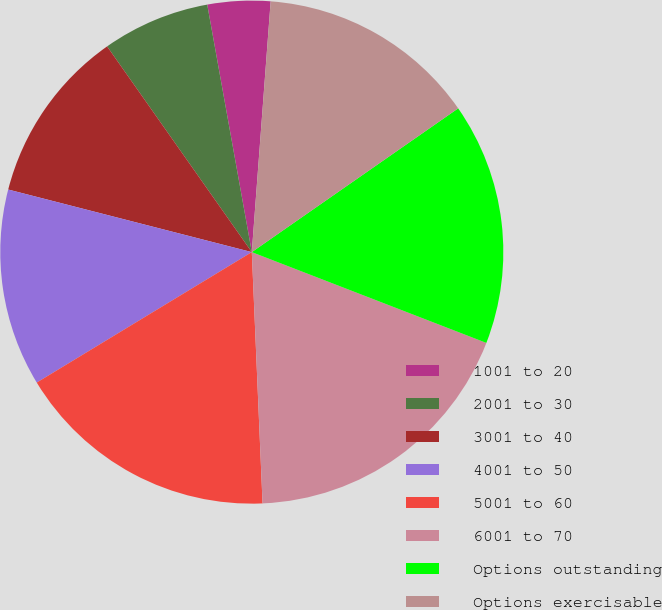Convert chart to OTSL. <chart><loc_0><loc_0><loc_500><loc_500><pie_chart><fcel>1001 to 20<fcel>2001 to 30<fcel>3001 to 40<fcel>4001 to 50<fcel>5001 to 60<fcel>6001 to 70<fcel>Options outstanding<fcel>Options exercisable<nl><fcel>4.03%<fcel>6.92%<fcel>11.24%<fcel>12.68%<fcel>17.0%<fcel>18.44%<fcel>15.56%<fcel>14.12%<nl></chart> 